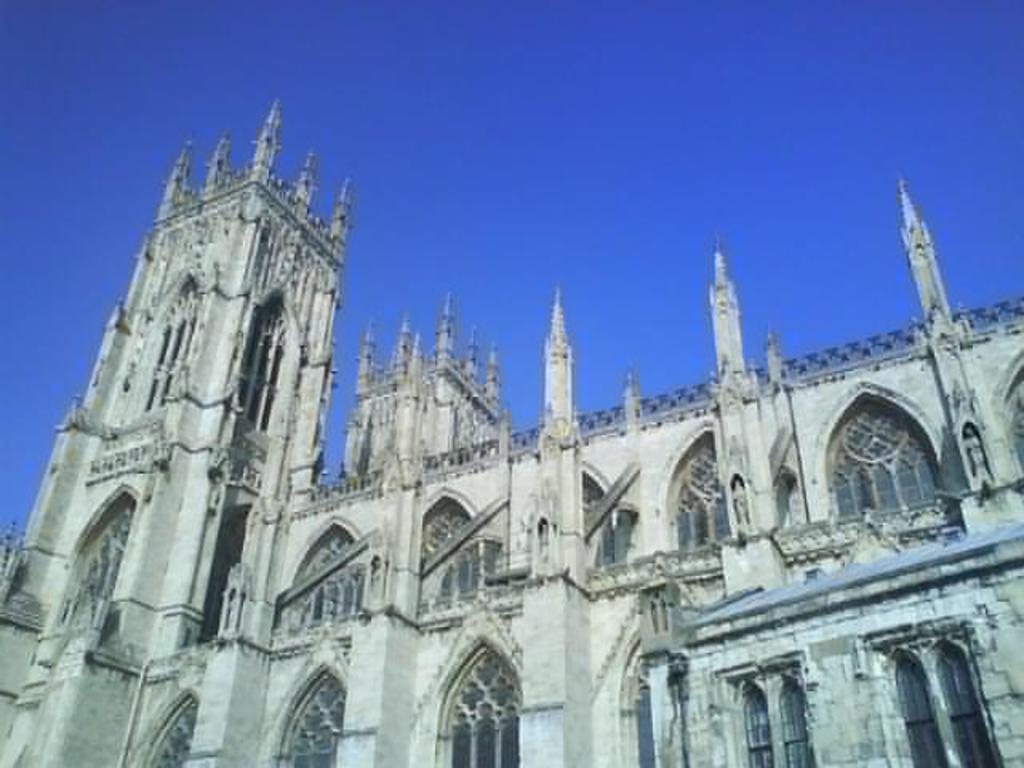Can you describe this image briefly? In this image in front there is a building. In the background of the image there is sky. 